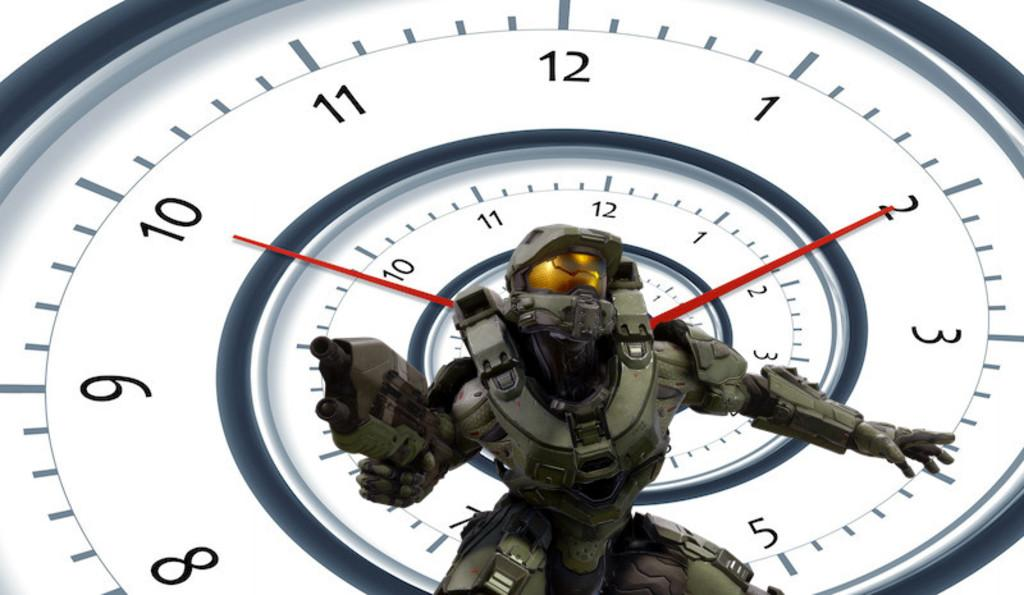<image>
Provide a brief description of the given image. A character is posing in front of a clock which is set to 10:10. 